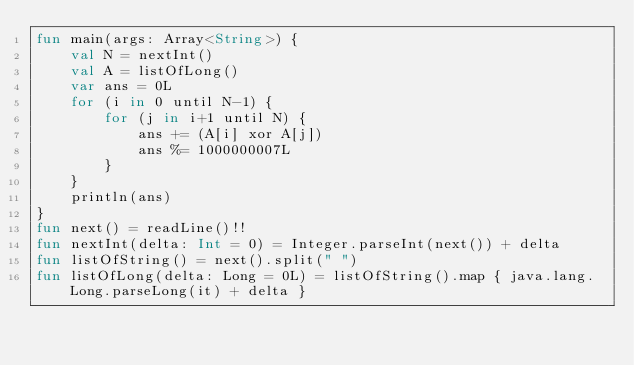Convert code to text. <code><loc_0><loc_0><loc_500><loc_500><_Kotlin_>fun main(args: Array<String>) {
    val N = nextInt()
    val A = listOfLong()
    var ans = 0L
    for (i in 0 until N-1) {
        for (j in i+1 until N) {
            ans += (A[i] xor A[j])
            ans %= 1000000007L
        }
    }
    println(ans)
}
fun next() = readLine()!!
fun nextInt(delta: Int = 0) = Integer.parseInt(next()) + delta
fun listOfString() = next().split(" ")
fun listOfLong(delta: Long = 0L) = listOfString().map { java.lang.Long.parseLong(it) + delta }</code> 